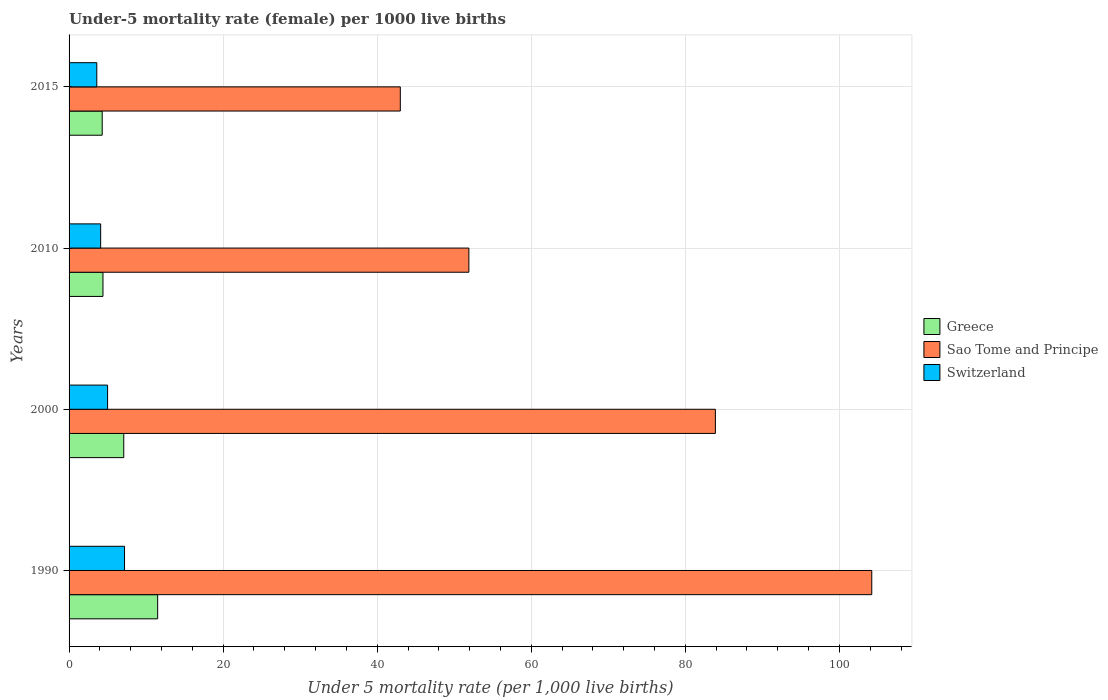How many different coloured bars are there?
Your answer should be compact. 3. Are the number of bars per tick equal to the number of legend labels?
Your response must be concise. Yes. Are the number of bars on each tick of the Y-axis equal?
Offer a very short reply. Yes. How many bars are there on the 1st tick from the top?
Make the answer very short. 3. Across all years, what is the maximum under-five mortality rate in Sao Tome and Principe?
Your answer should be very brief. 104.2. In which year was the under-five mortality rate in Sao Tome and Principe minimum?
Provide a succinct answer. 2015. What is the total under-five mortality rate in Sao Tome and Principe in the graph?
Provide a succinct answer. 283. What is the difference between the under-five mortality rate in Greece in 1990 and the under-five mortality rate in Sao Tome and Principe in 2000?
Provide a succinct answer. -72.4. What is the average under-five mortality rate in Switzerland per year?
Provide a short and direct response. 4.97. In the year 2015, what is the difference between the under-five mortality rate in Greece and under-five mortality rate in Sao Tome and Principe?
Your answer should be very brief. -38.7. In how many years, is the under-five mortality rate in Switzerland greater than 28 ?
Your response must be concise. 0. What is the ratio of the under-five mortality rate in Switzerland in 2000 to that in 2015?
Keep it short and to the point. 1.39. Is the under-five mortality rate in Switzerland in 2000 less than that in 2015?
Provide a succinct answer. No. What is the difference between the highest and the second highest under-five mortality rate in Sao Tome and Principe?
Provide a succinct answer. 20.3. In how many years, is the under-five mortality rate in Switzerland greater than the average under-five mortality rate in Switzerland taken over all years?
Keep it short and to the point. 2. Is the sum of the under-five mortality rate in Switzerland in 1990 and 2015 greater than the maximum under-five mortality rate in Sao Tome and Principe across all years?
Provide a short and direct response. No. What does the 2nd bar from the top in 2000 represents?
Your answer should be compact. Sao Tome and Principe. How many bars are there?
Provide a short and direct response. 12. Are all the bars in the graph horizontal?
Ensure brevity in your answer.  Yes. What is the difference between two consecutive major ticks on the X-axis?
Your response must be concise. 20. Does the graph contain grids?
Your answer should be very brief. Yes. How are the legend labels stacked?
Keep it short and to the point. Vertical. What is the title of the graph?
Ensure brevity in your answer.  Under-5 mortality rate (female) per 1000 live births. What is the label or title of the X-axis?
Provide a short and direct response. Under 5 mortality rate (per 1,0 live births). What is the label or title of the Y-axis?
Provide a succinct answer. Years. What is the Under 5 mortality rate (per 1,000 live births) of Sao Tome and Principe in 1990?
Provide a succinct answer. 104.2. What is the Under 5 mortality rate (per 1,000 live births) in Switzerland in 1990?
Offer a terse response. 7.2. What is the Under 5 mortality rate (per 1,000 live births) of Sao Tome and Principe in 2000?
Keep it short and to the point. 83.9. What is the Under 5 mortality rate (per 1,000 live births) in Switzerland in 2000?
Provide a short and direct response. 5. What is the Under 5 mortality rate (per 1,000 live births) of Greece in 2010?
Give a very brief answer. 4.4. What is the Under 5 mortality rate (per 1,000 live births) of Sao Tome and Principe in 2010?
Offer a very short reply. 51.9. What is the Under 5 mortality rate (per 1,000 live births) in Greece in 2015?
Provide a short and direct response. 4.3. What is the Under 5 mortality rate (per 1,000 live births) of Sao Tome and Principe in 2015?
Your answer should be compact. 43. What is the Under 5 mortality rate (per 1,000 live births) in Switzerland in 2015?
Your answer should be compact. 3.6. Across all years, what is the maximum Under 5 mortality rate (per 1,000 live births) in Greece?
Provide a short and direct response. 11.5. Across all years, what is the maximum Under 5 mortality rate (per 1,000 live births) in Sao Tome and Principe?
Ensure brevity in your answer.  104.2. Across all years, what is the minimum Under 5 mortality rate (per 1,000 live births) in Switzerland?
Provide a short and direct response. 3.6. What is the total Under 5 mortality rate (per 1,000 live births) of Greece in the graph?
Keep it short and to the point. 27.3. What is the total Under 5 mortality rate (per 1,000 live births) of Sao Tome and Principe in the graph?
Provide a short and direct response. 283. What is the total Under 5 mortality rate (per 1,000 live births) of Switzerland in the graph?
Give a very brief answer. 19.9. What is the difference between the Under 5 mortality rate (per 1,000 live births) in Sao Tome and Principe in 1990 and that in 2000?
Offer a very short reply. 20.3. What is the difference between the Under 5 mortality rate (per 1,000 live births) in Sao Tome and Principe in 1990 and that in 2010?
Keep it short and to the point. 52.3. What is the difference between the Under 5 mortality rate (per 1,000 live births) in Sao Tome and Principe in 1990 and that in 2015?
Provide a short and direct response. 61.2. What is the difference between the Under 5 mortality rate (per 1,000 live births) of Switzerland in 1990 and that in 2015?
Offer a terse response. 3.6. What is the difference between the Under 5 mortality rate (per 1,000 live births) in Greece in 2000 and that in 2010?
Give a very brief answer. 2.7. What is the difference between the Under 5 mortality rate (per 1,000 live births) in Sao Tome and Principe in 2000 and that in 2015?
Ensure brevity in your answer.  40.9. What is the difference between the Under 5 mortality rate (per 1,000 live births) of Sao Tome and Principe in 2010 and that in 2015?
Provide a short and direct response. 8.9. What is the difference between the Under 5 mortality rate (per 1,000 live births) of Greece in 1990 and the Under 5 mortality rate (per 1,000 live births) of Sao Tome and Principe in 2000?
Offer a terse response. -72.4. What is the difference between the Under 5 mortality rate (per 1,000 live births) of Greece in 1990 and the Under 5 mortality rate (per 1,000 live births) of Switzerland in 2000?
Give a very brief answer. 6.5. What is the difference between the Under 5 mortality rate (per 1,000 live births) of Sao Tome and Principe in 1990 and the Under 5 mortality rate (per 1,000 live births) of Switzerland in 2000?
Your answer should be very brief. 99.2. What is the difference between the Under 5 mortality rate (per 1,000 live births) of Greece in 1990 and the Under 5 mortality rate (per 1,000 live births) of Sao Tome and Principe in 2010?
Offer a very short reply. -40.4. What is the difference between the Under 5 mortality rate (per 1,000 live births) of Sao Tome and Principe in 1990 and the Under 5 mortality rate (per 1,000 live births) of Switzerland in 2010?
Offer a very short reply. 100.1. What is the difference between the Under 5 mortality rate (per 1,000 live births) in Greece in 1990 and the Under 5 mortality rate (per 1,000 live births) in Sao Tome and Principe in 2015?
Provide a short and direct response. -31.5. What is the difference between the Under 5 mortality rate (per 1,000 live births) of Sao Tome and Principe in 1990 and the Under 5 mortality rate (per 1,000 live births) of Switzerland in 2015?
Provide a short and direct response. 100.6. What is the difference between the Under 5 mortality rate (per 1,000 live births) in Greece in 2000 and the Under 5 mortality rate (per 1,000 live births) in Sao Tome and Principe in 2010?
Provide a succinct answer. -44.8. What is the difference between the Under 5 mortality rate (per 1,000 live births) in Sao Tome and Principe in 2000 and the Under 5 mortality rate (per 1,000 live births) in Switzerland in 2010?
Offer a very short reply. 79.8. What is the difference between the Under 5 mortality rate (per 1,000 live births) of Greece in 2000 and the Under 5 mortality rate (per 1,000 live births) of Sao Tome and Principe in 2015?
Offer a very short reply. -35.9. What is the difference between the Under 5 mortality rate (per 1,000 live births) in Greece in 2000 and the Under 5 mortality rate (per 1,000 live births) in Switzerland in 2015?
Ensure brevity in your answer.  3.5. What is the difference between the Under 5 mortality rate (per 1,000 live births) in Sao Tome and Principe in 2000 and the Under 5 mortality rate (per 1,000 live births) in Switzerland in 2015?
Make the answer very short. 80.3. What is the difference between the Under 5 mortality rate (per 1,000 live births) of Greece in 2010 and the Under 5 mortality rate (per 1,000 live births) of Sao Tome and Principe in 2015?
Offer a terse response. -38.6. What is the difference between the Under 5 mortality rate (per 1,000 live births) in Greece in 2010 and the Under 5 mortality rate (per 1,000 live births) in Switzerland in 2015?
Your answer should be compact. 0.8. What is the difference between the Under 5 mortality rate (per 1,000 live births) of Sao Tome and Principe in 2010 and the Under 5 mortality rate (per 1,000 live births) of Switzerland in 2015?
Offer a terse response. 48.3. What is the average Under 5 mortality rate (per 1,000 live births) of Greece per year?
Provide a short and direct response. 6.83. What is the average Under 5 mortality rate (per 1,000 live births) of Sao Tome and Principe per year?
Ensure brevity in your answer.  70.75. What is the average Under 5 mortality rate (per 1,000 live births) of Switzerland per year?
Ensure brevity in your answer.  4.97. In the year 1990, what is the difference between the Under 5 mortality rate (per 1,000 live births) of Greece and Under 5 mortality rate (per 1,000 live births) of Sao Tome and Principe?
Provide a succinct answer. -92.7. In the year 1990, what is the difference between the Under 5 mortality rate (per 1,000 live births) in Sao Tome and Principe and Under 5 mortality rate (per 1,000 live births) in Switzerland?
Offer a very short reply. 97. In the year 2000, what is the difference between the Under 5 mortality rate (per 1,000 live births) of Greece and Under 5 mortality rate (per 1,000 live births) of Sao Tome and Principe?
Ensure brevity in your answer.  -76.8. In the year 2000, what is the difference between the Under 5 mortality rate (per 1,000 live births) in Greece and Under 5 mortality rate (per 1,000 live births) in Switzerland?
Give a very brief answer. 2.1. In the year 2000, what is the difference between the Under 5 mortality rate (per 1,000 live births) in Sao Tome and Principe and Under 5 mortality rate (per 1,000 live births) in Switzerland?
Your answer should be very brief. 78.9. In the year 2010, what is the difference between the Under 5 mortality rate (per 1,000 live births) of Greece and Under 5 mortality rate (per 1,000 live births) of Sao Tome and Principe?
Offer a terse response. -47.5. In the year 2010, what is the difference between the Under 5 mortality rate (per 1,000 live births) in Sao Tome and Principe and Under 5 mortality rate (per 1,000 live births) in Switzerland?
Your answer should be compact. 47.8. In the year 2015, what is the difference between the Under 5 mortality rate (per 1,000 live births) in Greece and Under 5 mortality rate (per 1,000 live births) in Sao Tome and Principe?
Provide a succinct answer. -38.7. In the year 2015, what is the difference between the Under 5 mortality rate (per 1,000 live births) in Greece and Under 5 mortality rate (per 1,000 live births) in Switzerland?
Offer a terse response. 0.7. In the year 2015, what is the difference between the Under 5 mortality rate (per 1,000 live births) of Sao Tome and Principe and Under 5 mortality rate (per 1,000 live births) of Switzerland?
Your answer should be compact. 39.4. What is the ratio of the Under 5 mortality rate (per 1,000 live births) in Greece in 1990 to that in 2000?
Your response must be concise. 1.62. What is the ratio of the Under 5 mortality rate (per 1,000 live births) in Sao Tome and Principe in 1990 to that in 2000?
Your response must be concise. 1.24. What is the ratio of the Under 5 mortality rate (per 1,000 live births) of Switzerland in 1990 to that in 2000?
Make the answer very short. 1.44. What is the ratio of the Under 5 mortality rate (per 1,000 live births) in Greece in 1990 to that in 2010?
Ensure brevity in your answer.  2.61. What is the ratio of the Under 5 mortality rate (per 1,000 live births) in Sao Tome and Principe in 1990 to that in 2010?
Give a very brief answer. 2.01. What is the ratio of the Under 5 mortality rate (per 1,000 live births) in Switzerland in 1990 to that in 2010?
Offer a terse response. 1.76. What is the ratio of the Under 5 mortality rate (per 1,000 live births) of Greece in 1990 to that in 2015?
Make the answer very short. 2.67. What is the ratio of the Under 5 mortality rate (per 1,000 live births) of Sao Tome and Principe in 1990 to that in 2015?
Your answer should be very brief. 2.42. What is the ratio of the Under 5 mortality rate (per 1,000 live births) in Switzerland in 1990 to that in 2015?
Offer a terse response. 2. What is the ratio of the Under 5 mortality rate (per 1,000 live births) in Greece in 2000 to that in 2010?
Make the answer very short. 1.61. What is the ratio of the Under 5 mortality rate (per 1,000 live births) in Sao Tome and Principe in 2000 to that in 2010?
Provide a short and direct response. 1.62. What is the ratio of the Under 5 mortality rate (per 1,000 live births) in Switzerland in 2000 to that in 2010?
Make the answer very short. 1.22. What is the ratio of the Under 5 mortality rate (per 1,000 live births) of Greece in 2000 to that in 2015?
Offer a very short reply. 1.65. What is the ratio of the Under 5 mortality rate (per 1,000 live births) in Sao Tome and Principe in 2000 to that in 2015?
Give a very brief answer. 1.95. What is the ratio of the Under 5 mortality rate (per 1,000 live births) of Switzerland in 2000 to that in 2015?
Give a very brief answer. 1.39. What is the ratio of the Under 5 mortality rate (per 1,000 live births) of Greece in 2010 to that in 2015?
Give a very brief answer. 1.02. What is the ratio of the Under 5 mortality rate (per 1,000 live births) in Sao Tome and Principe in 2010 to that in 2015?
Give a very brief answer. 1.21. What is the ratio of the Under 5 mortality rate (per 1,000 live births) of Switzerland in 2010 to that in 2015?
Ensure brevity in your answer.  1.14. What is the difference between the highest and the second highest Under 5 mortality rate (per 1,000 live births) of Sao Tome and Principe?
Make the answer very short. 20.3. What is the difference between the highest and the second highest Under 5 mortality rate (per 1,000 live births) of Switzerland?
Offer a terse response. 2.2. What is the difference between the highest and the lowest Under 5 mortality rate (per 1,000 live births) in Greece?
Your answer should be very brief. 7.2. What is the difference between the highest and the lowest Under 5 mortality rate (per 1,000 live births) of Sao Tome and Principe?
Your response must be concise. 61.2. What is the difference between the highest and the lowest Under 5 mortality rate (per 1,000 live births) in Switzerland?
Offer a terse response. 3.6. 